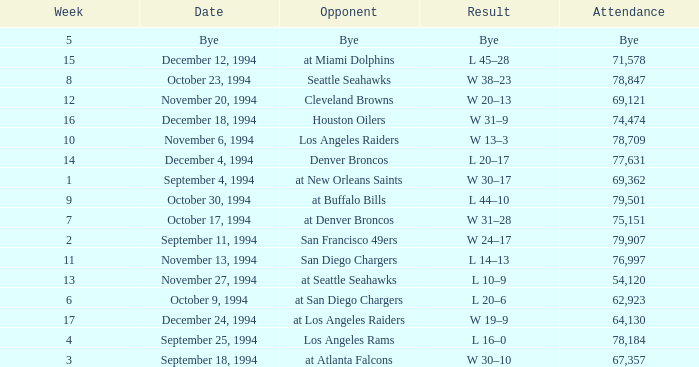What was the score of the Chiefs pre-Week 16 game that 69,362 people attended? W 30–17. 